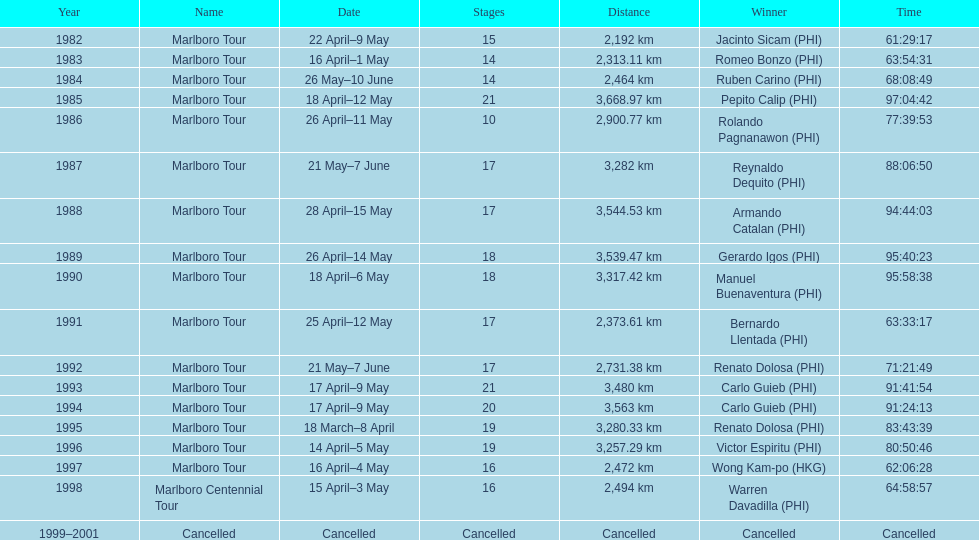What was the overall count of victors before the tour was called off? 17. 